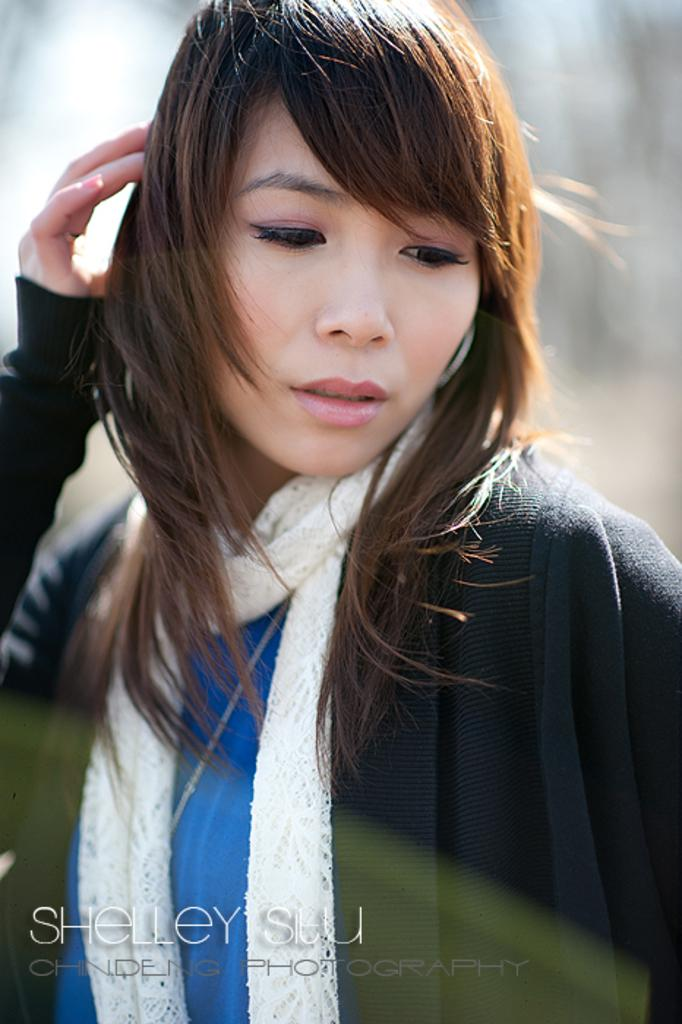What is the main subject of the image? There is a person in the image. Can you describe any additional details about the person? Unfortunately, the provided facts do not offer any additional details about the person. What is written at the bottom of the image? There is some text at the bottom of the image. Can you provide any information about the content of the text? Unfortunately, the provided facts do not offer any information about the content of the text. How many muscles does the person have in the image? The provided facts do not offer any information about the person's muscles, so it is impossible to determine the number of muscles in the image. 